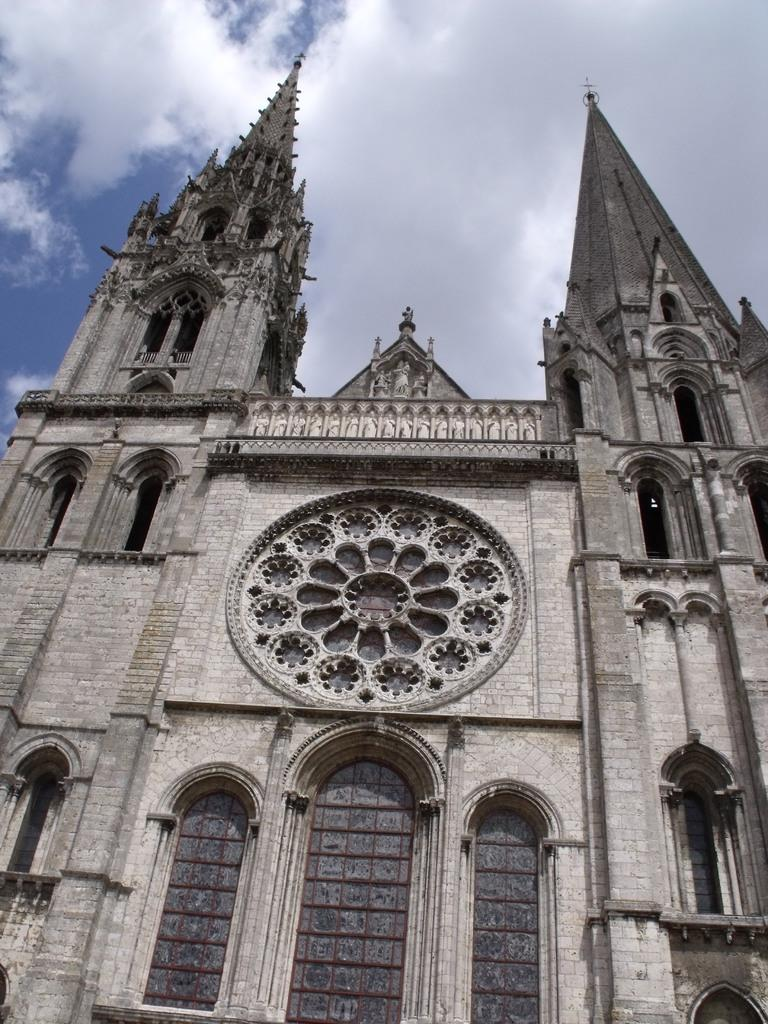What is the main structure in the image? There is a building in the image. What feature can be seen on the building? The building has windows. What can be seen in the sky in the image? There are clouds visible in the image. What else is visible in the sky in the image? The sky is visible in the image. How many lead pipes can be seen in the image? There are no lead pipes visible in the image. What type of tooth is present in the image? There are no teeth present in the image. 